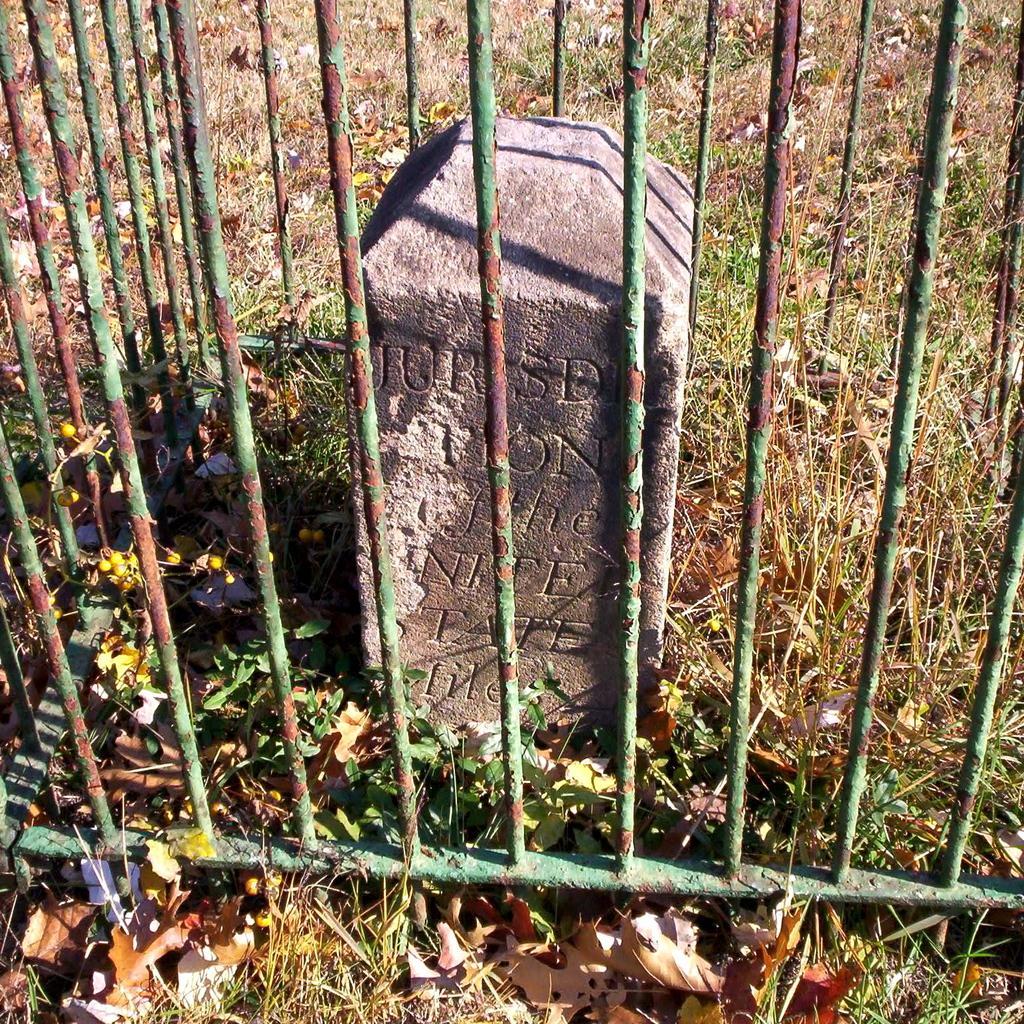Please provide a concise description of this image. In this image I can see number of iron bars, leaves on ground, grass, a stone and on it I can see something is written. 